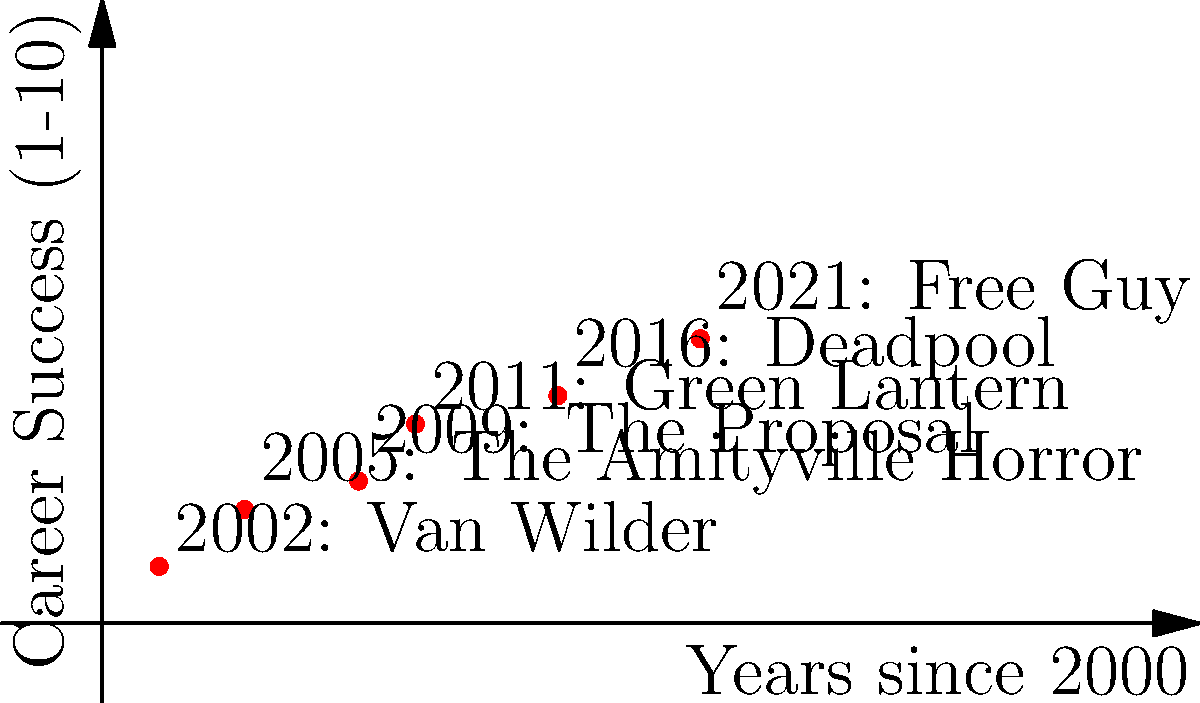In the polar coordinate plot of Ryan Reynolds' career trajectory, which movie marks the most significant turning point, represented by the largest angular change between two consecutive points? To determine the most significant turning point in Ryan Reynolds' career trajectory using polar coordinates, we need to follow these steps:

1. Convert the given Cartesian coordinates (years since 2000, success rating) to polar coordinates $(r, \theta)$:
   $r = \sqrt{x^2 + y^2}$
   $\theta = \arctan(\frac{y}{x})$

2. Calculate the polar coordinates for each point:
   2002: $(r_1, \theta_1) \approx (2.83, 0.785)$
   2005: $(r_2, \theta_2) \approx (6.40, 0.675)$
   2009: $(r_3, \theta_3) \approx (10.30, 0.507)$
   2011: $(r_4, \theta_4) \approx (13.04, 0.566)$
   2016: $(r_5, \theta_5) \approx (17.89, 0.464)$
   2021: $(r_6, \theta_6) \approx (23.26, 0.444)$

3. Calculate the angular change between consecutive points:
   $\Delta\theta_{1-2} = |\theta_2 - \theta_1| \approx 0.110$
   $\Delta\theta_{2-3} = |\theta_3 - \theta_2| \approx 0.168$
   $\Delta\theta_{3-4} = |\theta_4 - \theta_3| \approx 0.059$
   $\Delta\theta_{4-5} = |\theta_5 - \theta_4| \approx 0.102$
   $\Delta\theta_{5-6} = |\theta_6 - \theta_5| \approx 0.020$

4. Identify the largest angular change:
   The largest angular change is $\Delta\theta_{2-3} \approx 0.168$, which occurs between 2005 (The Amityville Horror) and 2009 (The Proposal).

Therefore, the movie that marks the most significant turning point in Ryan Reynolds' career trajectory is "The Proposal" (2009).
Answer: The Proposal (2009) 